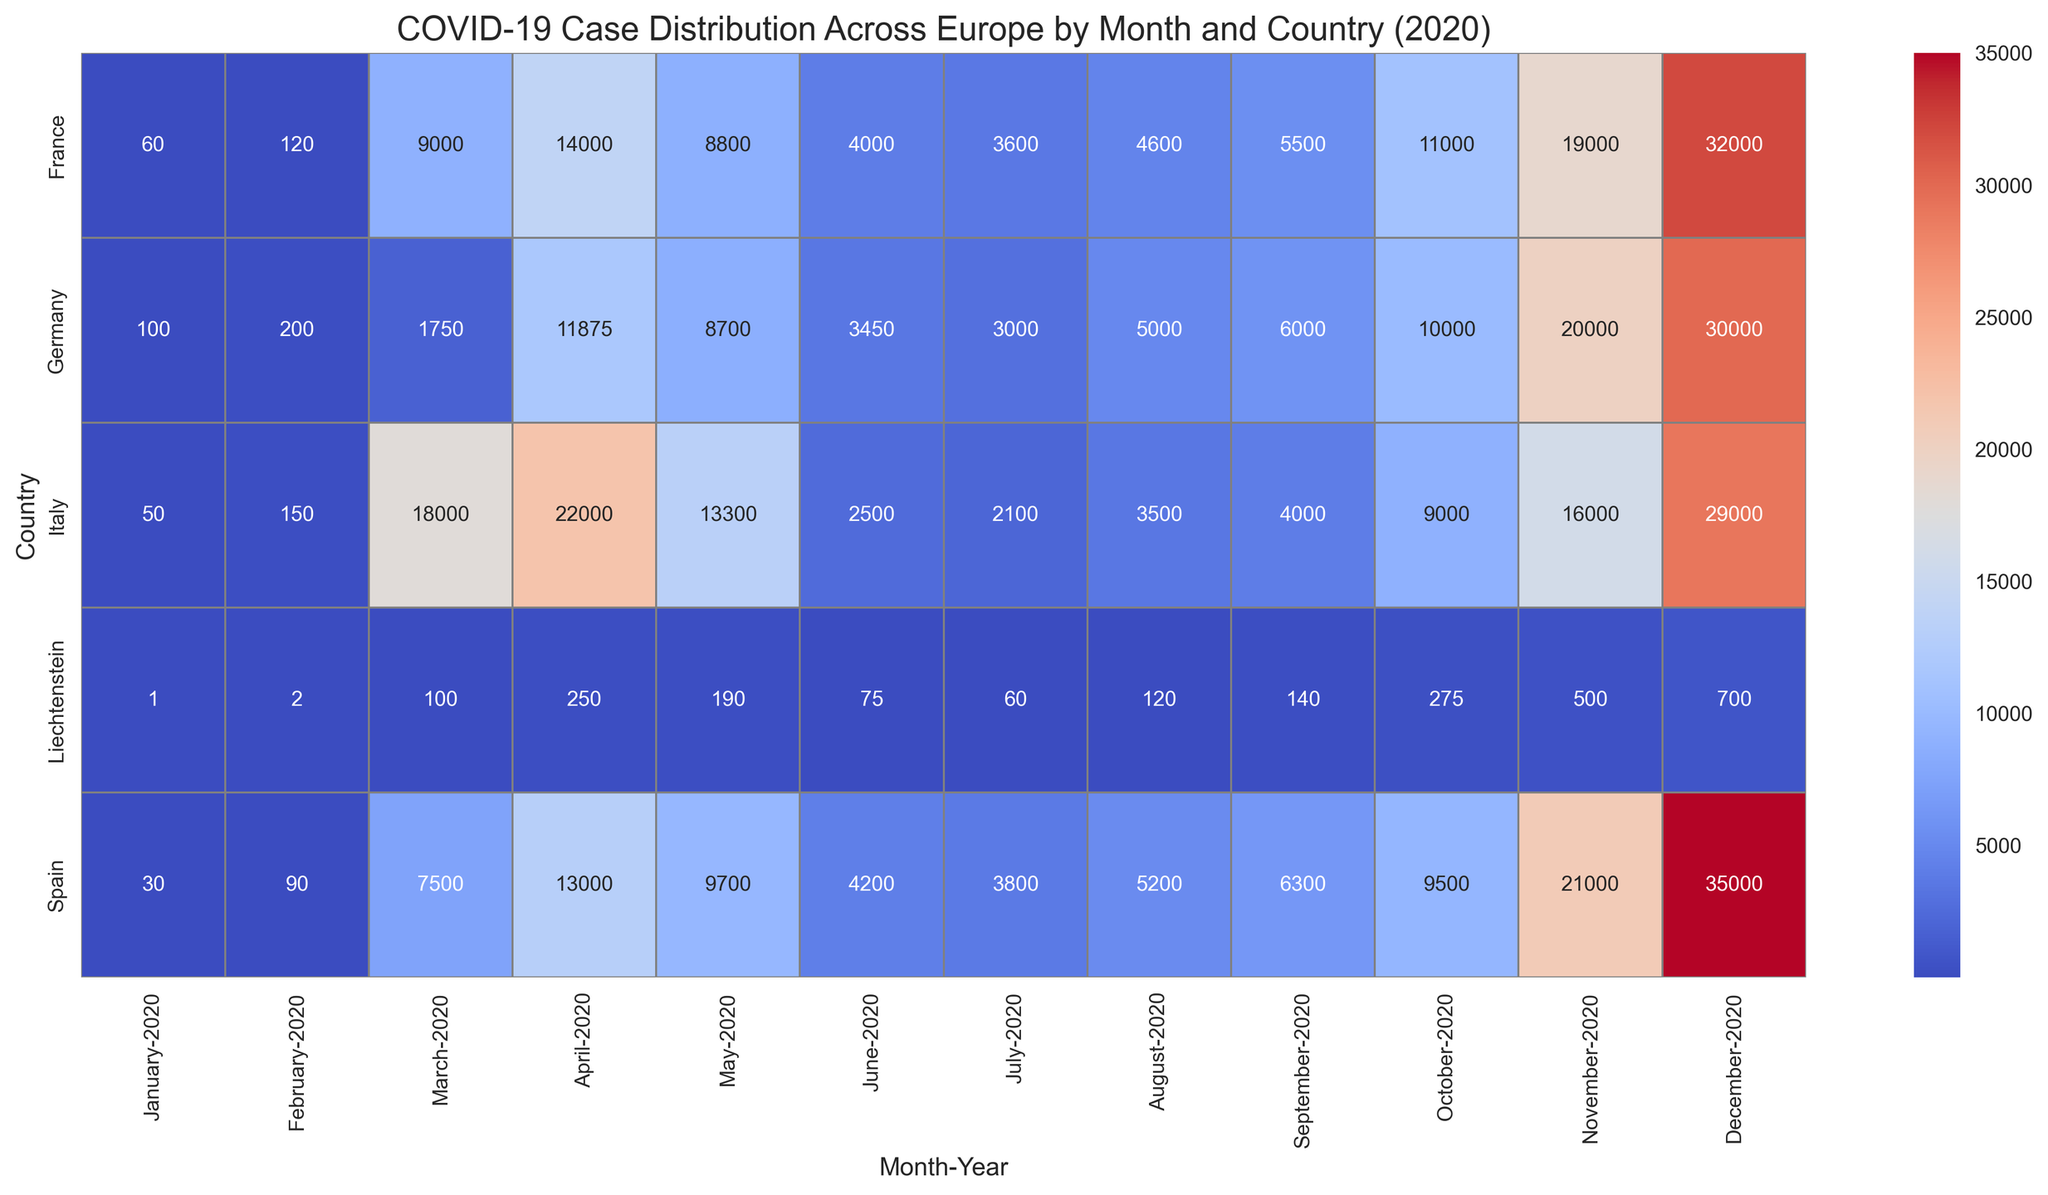Which country reported the highest number of COVID-19 cases in December 2020? By checking the heatmap for the month of December 2020, it's clear that Spain has the darkest shade, indicating the highest number of cases.
Answer: Spain Between France and Germany, which country experienced a higher number of cases in April 2020? By comparing the cells for April 2020 for both France and Germany, France has a higher case count.
Answer: France Which country saw the smallest increase in cases from January to February 2020? Liechtenstein had an increase from 1 case in January to 2 cases in February, which is the smallest increase compared to other countries.
Answer: Liechtenstein What's the difference in the number of COVID-19 cases between Italy and Spain in May 2020? The number of cases in Italy in May 2020 is 13300, while in Spain, it is 9700. The difference can be calculated as 13300 - 9700 = 3600.
Answer: 3600 Identify the month and country with the lowest number of reported cases. By examining the heatmap, Liechtenstein in January 2020 has the lightest shade, indicating the lowest number of cases.
Answer: Liechtenstein, January 2020 Which month shows the highest increase in cases for Germany from the previous month? Comparing month-to-month increases in the heatmap, the largest jump in color intensity occurs between March and April 2020, indicating the highest increase.
Answer: April 2020 Compare the total number of cases in the first quarter of 2020 (January-March) for France and Italy. Which country had more cases? Summing up the values for France: 60 (Jan) + 120 (Feb) + 9000 (Mar) = 9180, and for Italy: 50 (Jan) + 150 (Feb) + 18000 (Mar) = 18150. Italy had more cases.
Answer: Italy Which country had the most consistent number of cases across the months of July to September 2020? By checking the heatmap for cells from July to September, Germany shows values with less variation (3000 - 3450 - 3000).
Answer: Germany What's the combined number of cases in September 2020 for all countries? Summing up the values in September 2020 for all countries: Germany (6000) + Italy (4000) + France (5500) + Spain (6300) + Liechtenstein (140) results in a total of 21940.
Answer: 21940 